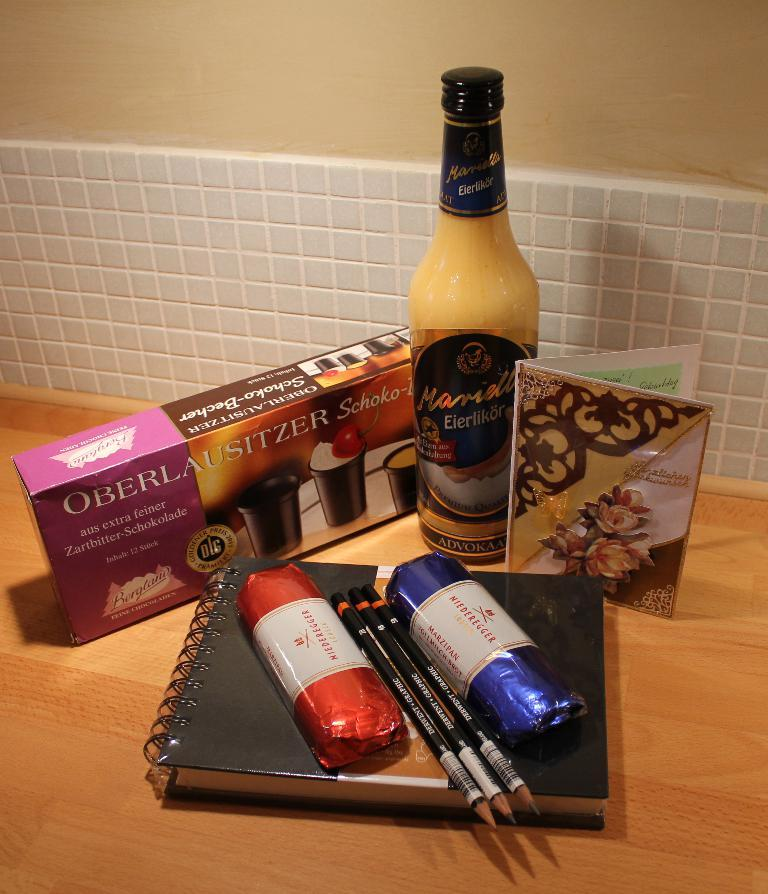What is the main object on the table in the image? There is a diary in the image. What writing instruments are present in the image? There are pencils in the image. What type of food can be seen in the image? There are cookies in the image. What beverage is visible in the image? There is a drink in the image. What type of stationery is present in the image? There is a greeting card in the image. Where are the objects located in the image? The objects are on a table. What is visible behind the table in the image? There is a wall behind the table. How does the visitor smash the cookies in the image? There is no visitor present in the image, and therefore no smashing of cookies can be observed. 